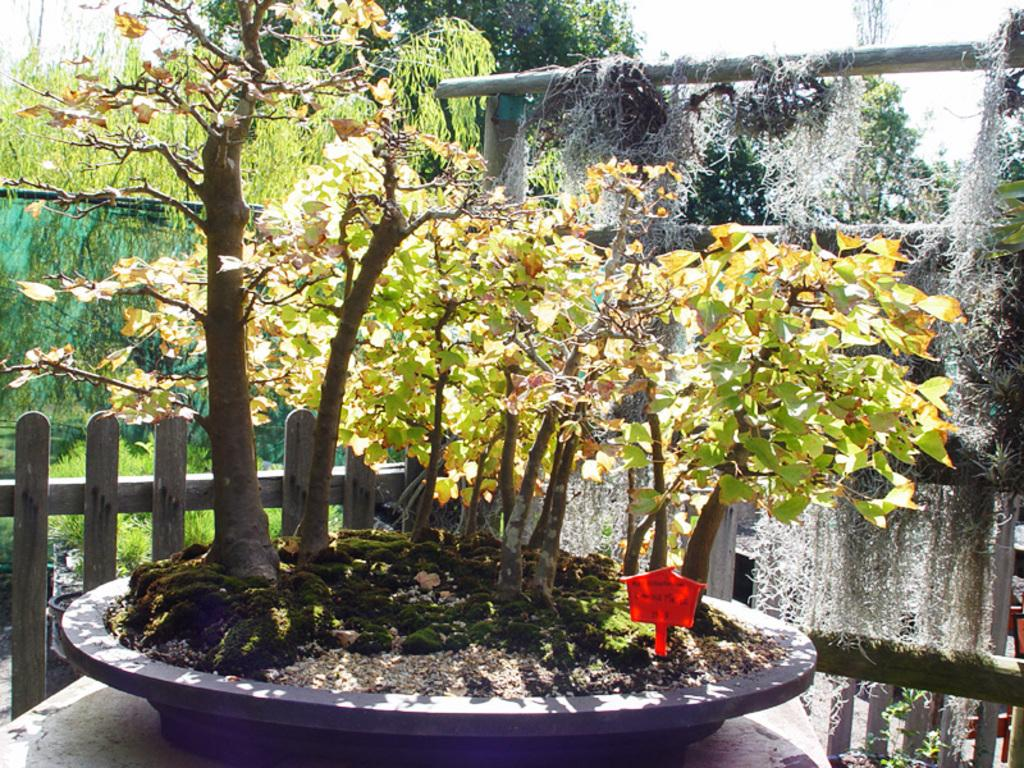What type of living organisms can be seen in the image? Plants and trees are visible in the image. What type of fencing is present in the foreground of the image? There is wooden fencing in the foreground of the image. Can you describe the trees in the image? The image contains trees, but no specific details about their type or appearance are provided. What type of club can be seen in the image? There is no club present in the image; it features plants, trees, and wooden fencing. How many cents are visible in the image? There are no cents or any form of currency present in the image. 